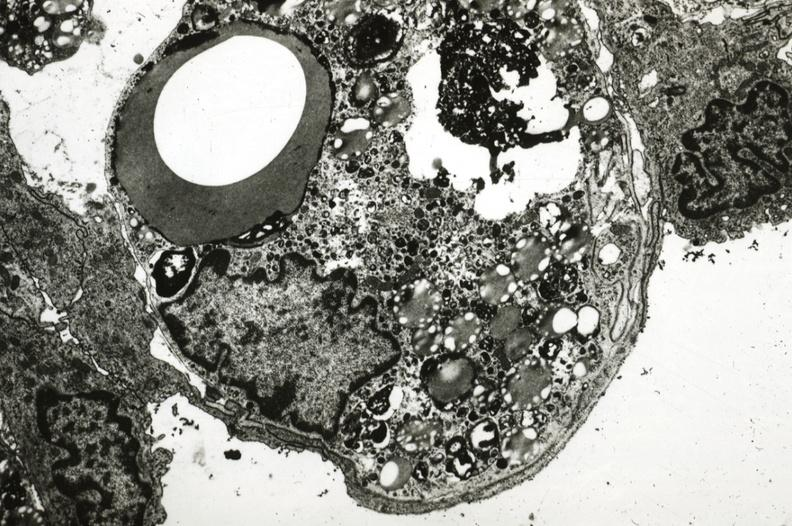what is present?
Answer the question using a single word or phrase. Aorta 